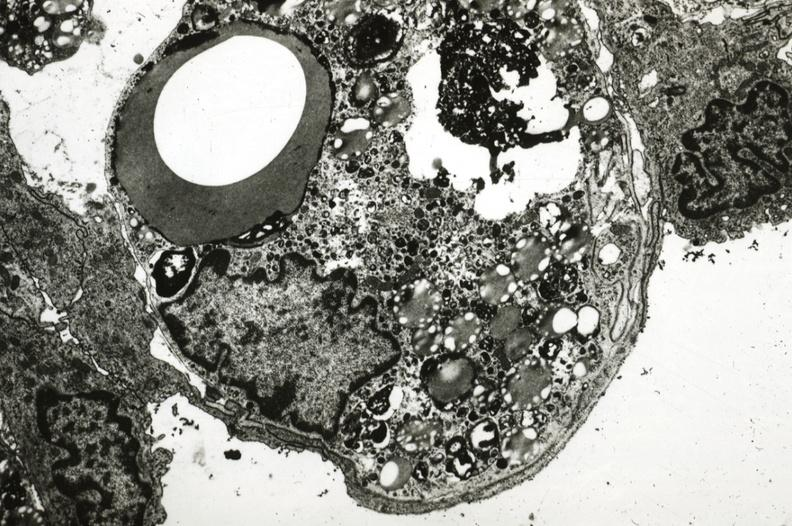what is present?
Answer the question using a single word or phrase. Aorta 